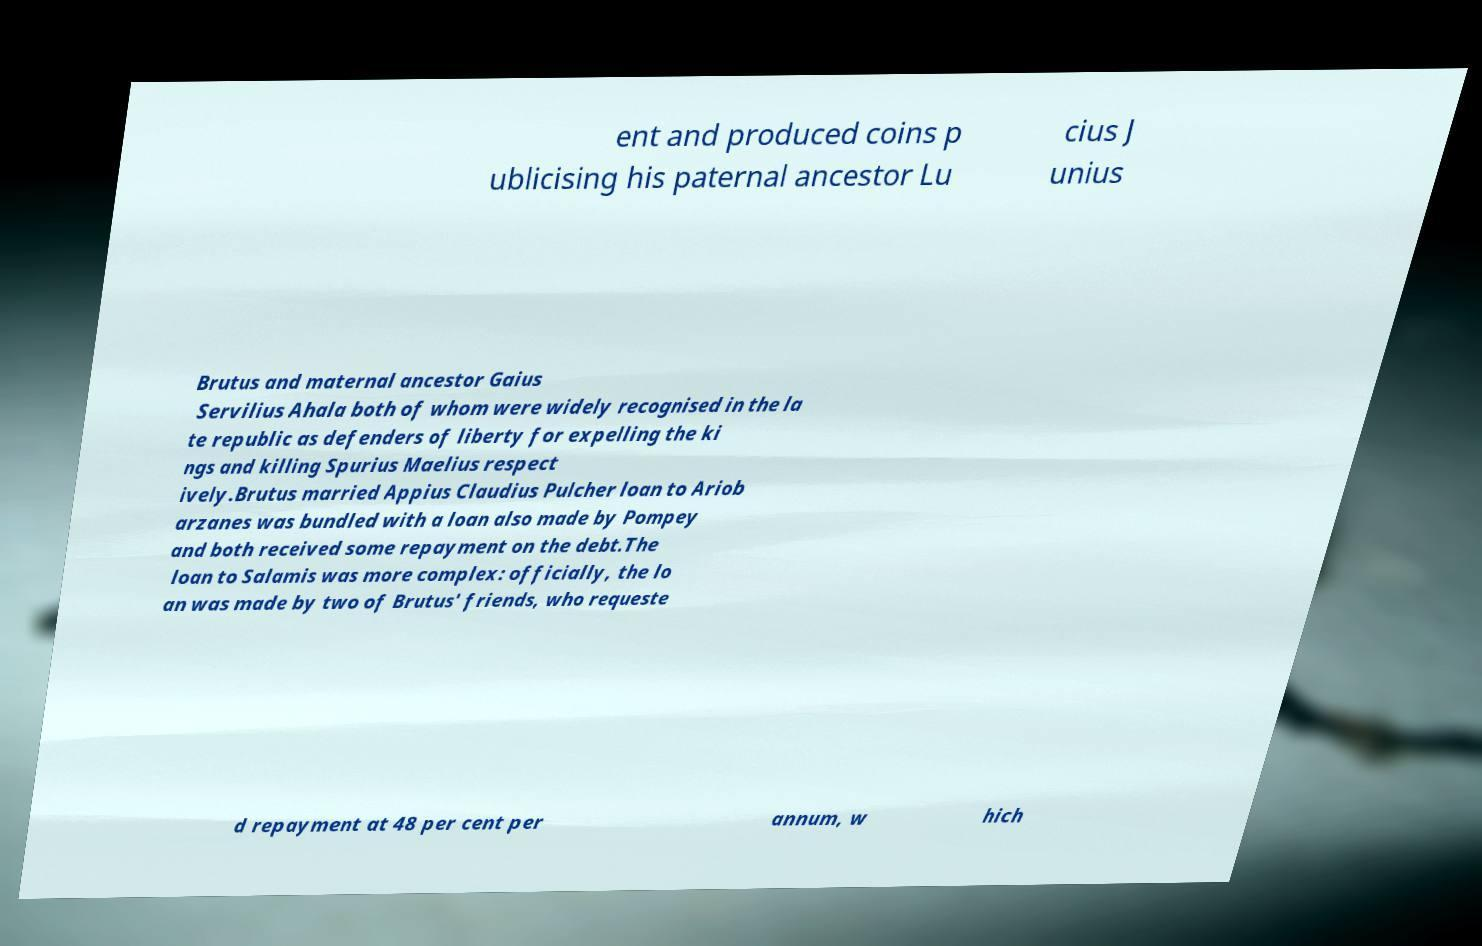Could you assist in decoding the text presented in this image and type it out clearly? ent and produced coins p ublicising his paternal ancestor Lu cius J unius Brutus and maternal ancestor Gaius Servilius Ahala both of whom were widely recognised in the la te republic as defenders of liberty for expelling the ki ngs and killing Spurius Maelius respect ively.Brutus married Appius Claudius Pulcher loan to Ariob arzanes was bundled with a loan also made by Pompey and both received some repayment on the debt.The loan to Salamis was more complex: officially, the lo an was made by two of Brutus' friends, who requeste d repayment at 48 per cent per annum, w hich 